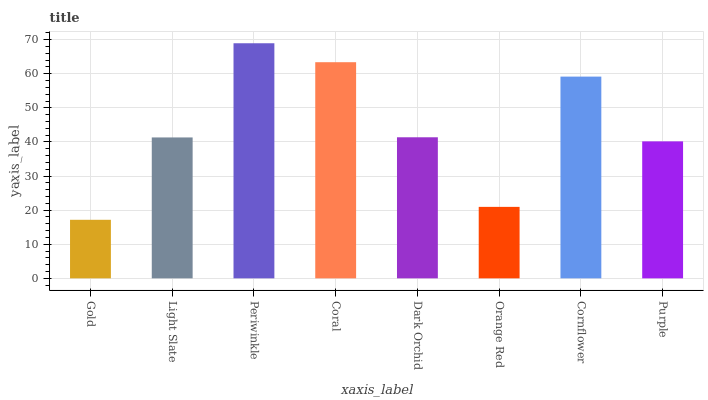Is Gold the minimum?
Answer yes or no. Yes. Is Periwinkle the maximum?
Answer yes or no. Yes. Is Light Slate the minimum?
Answer yes or no. No. Is Light Slate the maximum?
Answer yes or no. No. Is Light Slate greater than Gold?
Answer yes or no. Yes. Is Gold less than Light Slate?
Answer yes or no. Yes. Is Gold greater than Light Slate?
Answer yes or no. No. Is Light Slate less than Gold?
Answer yes or no. No. Is Dark Orchid the high median?
Answer yes or no. Yes. Is Light Slate the low median?
Answer yes or no. Yes. Is Light Slate the high median?
Answer yes or no. No. Is Coral the low median?
Answer yes or no. No. 